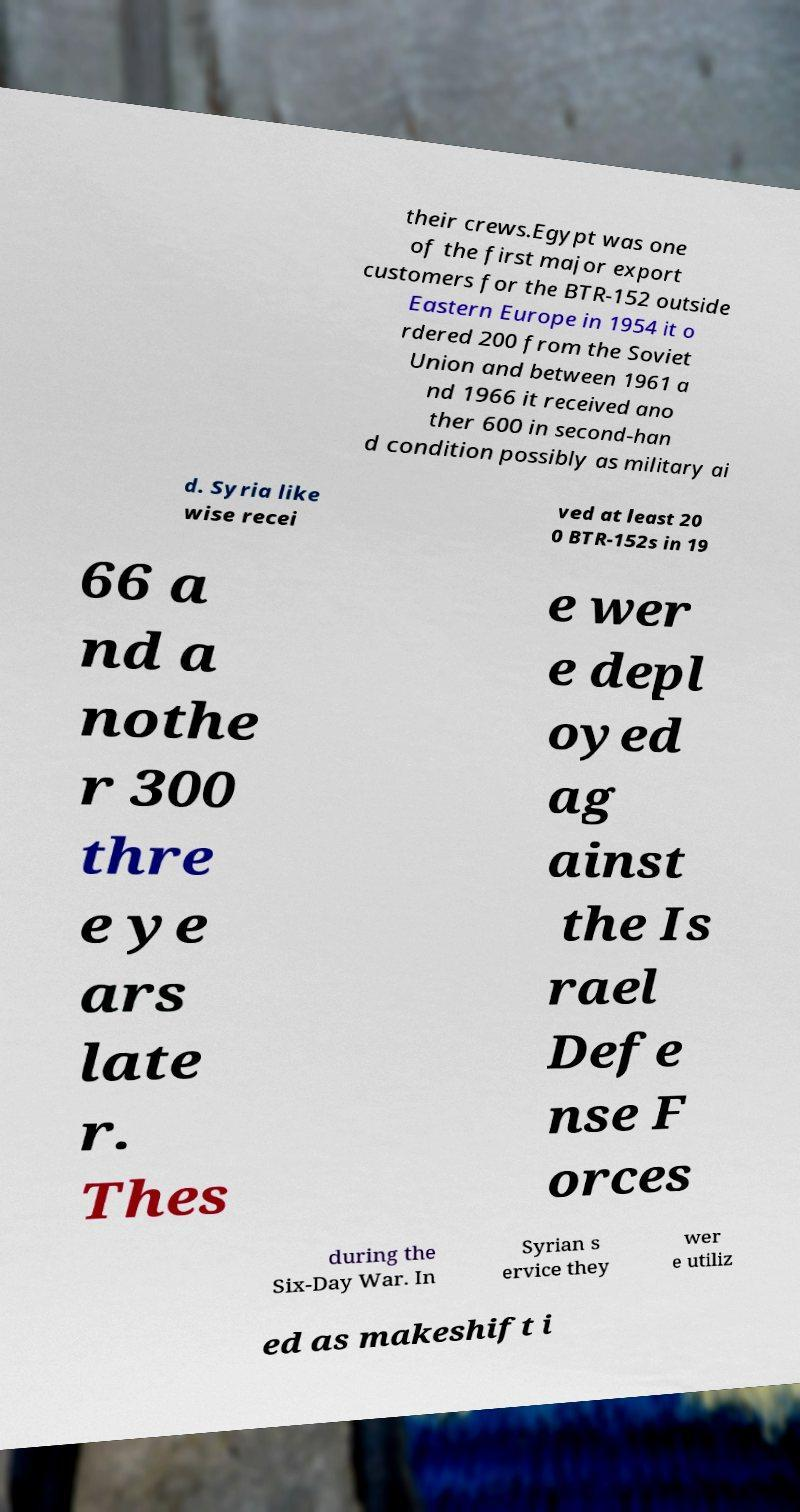What messages or text are displayed in this image? I need them in a readable, typed format. their crews.Egypt was one of the first major export customers for the BTR-152 outside Eastern Europe in 1954 it o rdered 200 from the Soviet Union and between 1961 a nd 1966 it received ano ther 600 in second-han d condition possibly as military ai d. Syria like wise recei ved at least 20 0 BTR-152s in 19 66 a nd a nothe r 300 thre e ye ars late r. Thes e wer e depl oyed ag ainst the Is rael Defe nse F orces during the Six-Day War. In Syrian s ervice they wer e utiliz ed as makeshift i 